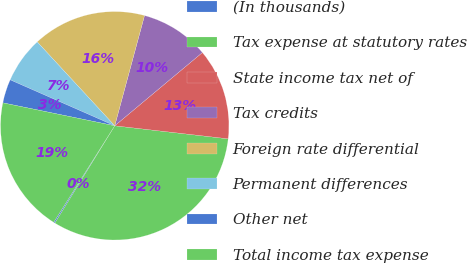Convert chart. <chart><loc_0><loc_0><loc_500><loc_500><pie_chart><fcel>(In thousands)<fcel>Tax expense at statutory rates<fcel>State income tax net of<fcel>Tax credits<fcel>Foreign rate differential<fcel>Permanent differences<fcel>Other net<fcel>Total income tax expense<nl><fcel>0.19%<fcel>31.96%<fcel>12.9%<fcel>9.72%<fcel>16.07%<fcel>6.54%<fcel>3.37%<fcel>19.25%<nl></chart> 